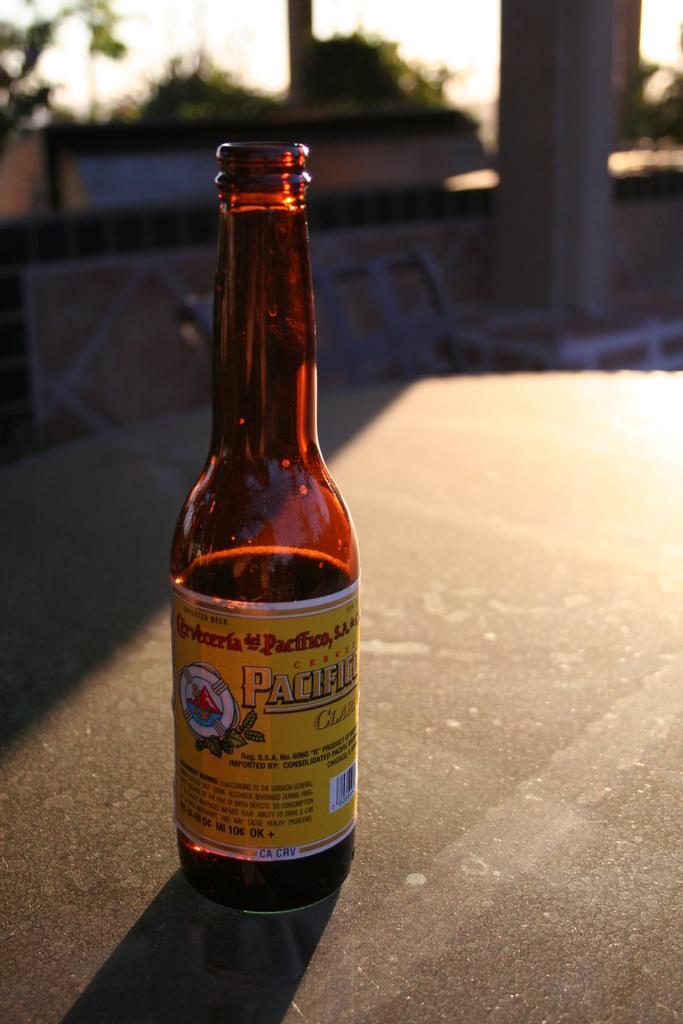<image>
Summarize the visual content of the image. a half full beer with CA CRV refund label standing on the table 